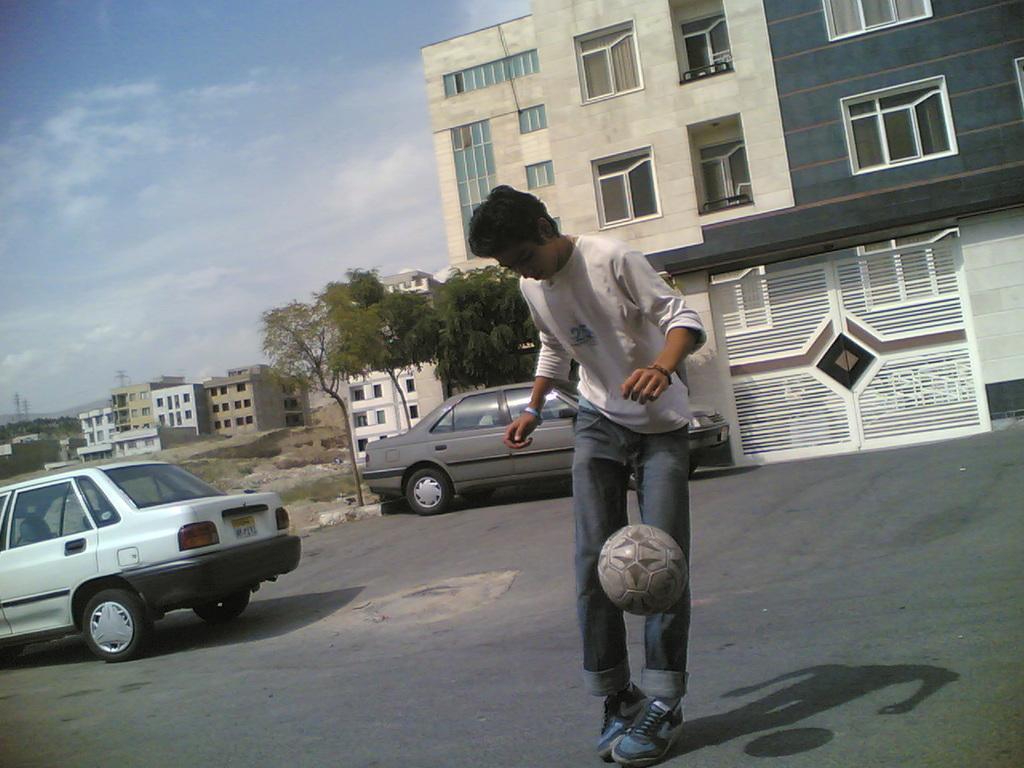Can you describe this image briefly? A man is playing football on the road. Behind him there are buildings,two cars,trees,sky with clouds. 